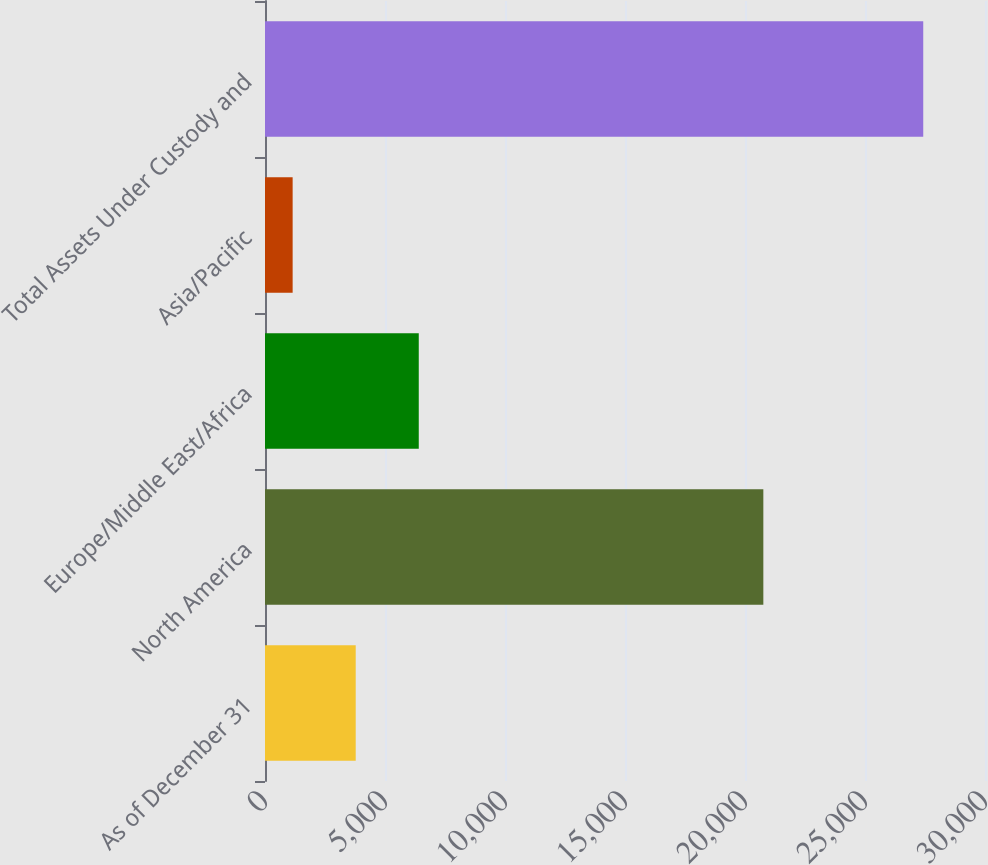<chart> <loc_0><loc_0><loc_500><loc_500><bar_chart><fcel>As of December 31<fcel>North America<fcel>Europe/Middle East/Africa<fcel>Asia/Pacific<fcel>Total Assets Under Custody and<nl><fcel>3779.5<fcel>20764<fcel>6407<fcel>1152<fcel>27427<nl></chart> 